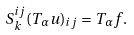<formula> <loc_0><loc_0><loc_500><loc_500>S _ { k } ^ { i j } ( T _ { \alpha } u ) _ { i j } = T _ { \alpha } f .</formula> 